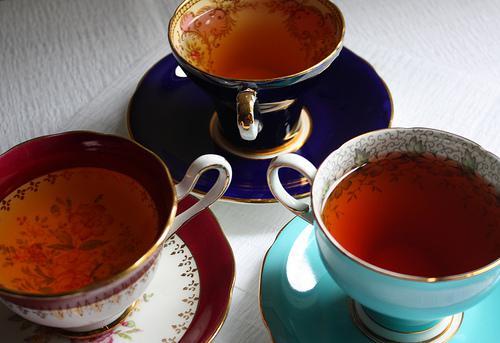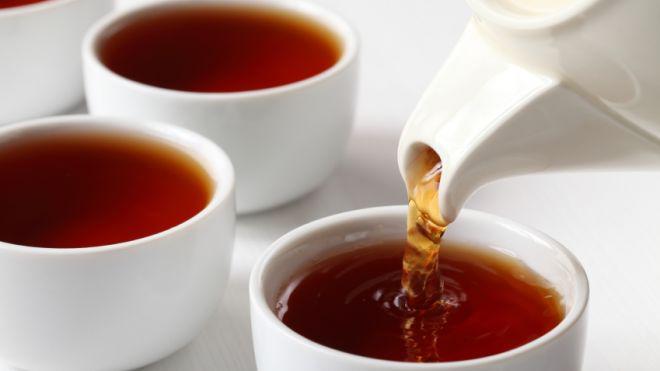The first image is the image on the left, the second image is the image on the right. Examine the images to the left and right. Is the description "There is at least one spoon placed in a saucer." accurate? Answer yes or no. No. The first image is the image on the left, the second image is the image on the right. Examine the images to the left and right. Is the description "Cups in the right image are on saucers, and cups in the left image are not." accurate? Answer yes or no. No. 